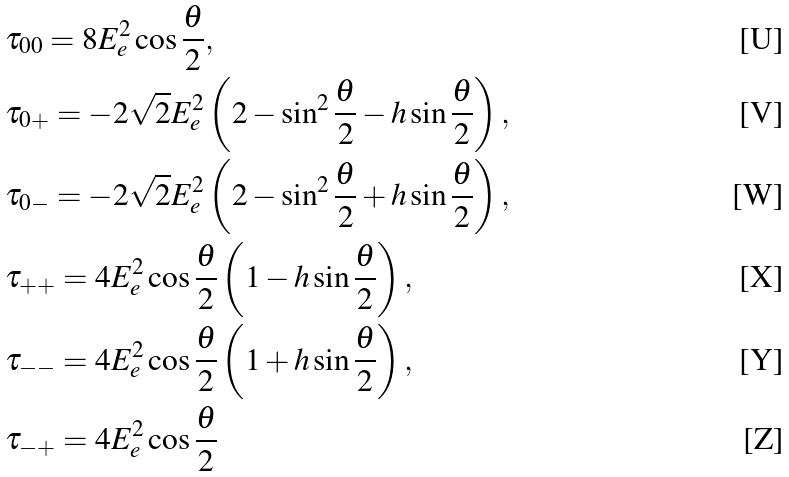Convert formula to latex. <formula><loc_0><loc_0><loc_500><loc_500>& \tau _ { 0 0 } = 8 E _ { e } ^ { 2 } \cos \frac { \theta } 2 , \\ & \tau _ { 0 + } = - 2 \sqrt { 2 } E _ { e } ^ { 2 } \left ( 2 - \sin ^ { 2 } \frac { \theta } 2 - h \sin \frac { \theta } 2 \right ) , \\ & \tau _ { 0 - } = - 2 \sqrt { 2 } E _ { e } ^ { 2 } \left ( 2 - \sin ^ { 2 } \frac { \theta } 2 + h \sin \frac { \theta } 2 \right ) , \\ & \tau _ { + + } = 4 E _ { e } ^ { 2 } \cos \frac { \theta } 2 \left ( 1 - h \sin \frac { \theta } 2 \right ) , \\ & \tau _ { - - } = 4 E _ { e } ^ { 2 } \cos \frac { \theta } 2 \left ( 1 + h \sin \frac { \theta } 2 \right ) , \\ & \tau _ { - + } = 4 E _ { e } ^ { 2 } \cos \frac { \theta } 2</formula> 